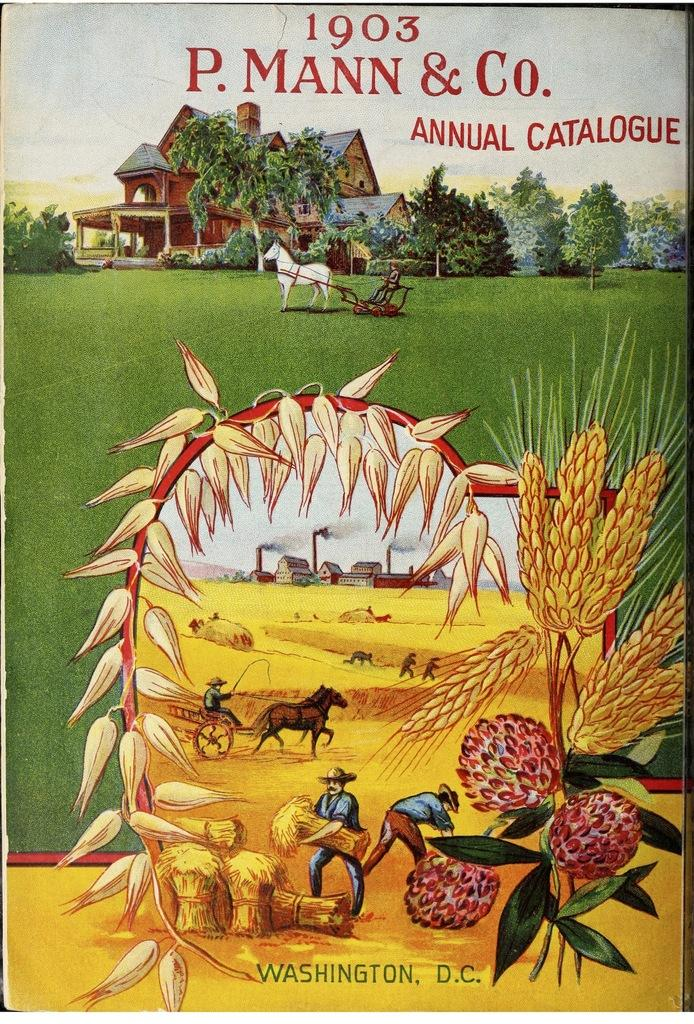What types of images can be found on the cover page of the book? The cover page of the book contains images of a few persons, buildings, plants, trees, and animals. Can you describe the sky on the cover page? The sky is visible on the cover page. How does the party on the cover page compare to the war in the image? There is no party or war present on the cover page; it contains images of persons, buildings, plants, trees, and animals, along with a visible sky. 